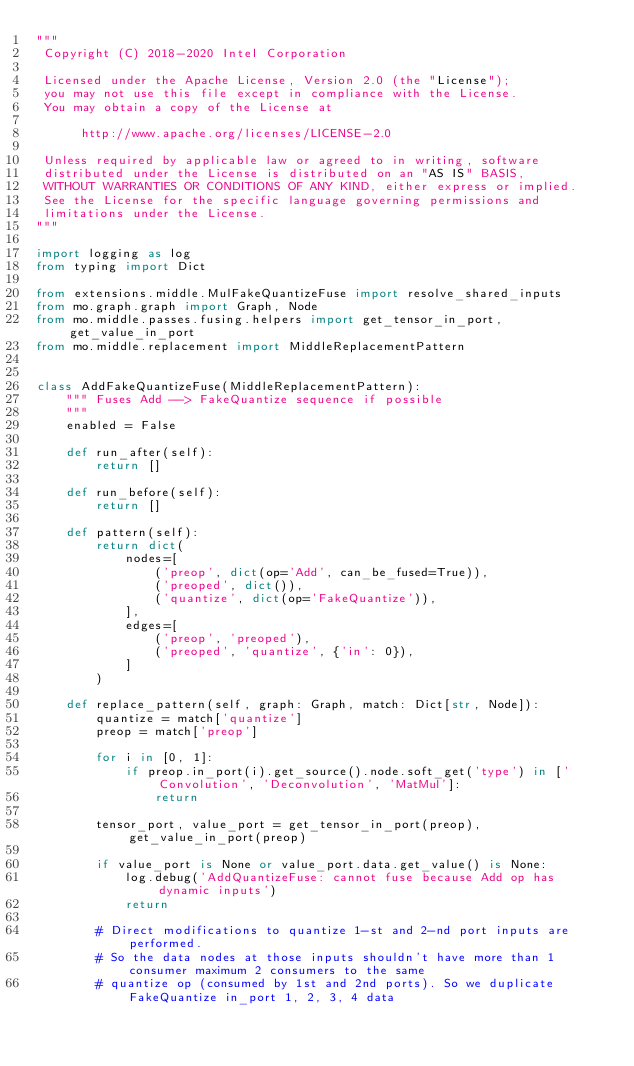<code> <loc_0><loc_0><loc_500><loc_500><_Python_>"""
 Copyright (C) 2018-2020 Intel Corporation

 Licensed under the Apache License, Version 2.0 (the "License");
 you may not use this file except in compliance with the License.
 You may obtain a copy of the License at

      http://www.apache.org/licenses/LICENSE-2.0

 Unless required by applicable law or agreed to in writing, software
 distributed under the License is distributed on an "AS IS" BASIS,
 WITHOUT WARRANTIES OR CONDITIONS OF ANY KIND, either express or implied.
 See the License for the specific language governing permissions and
 limitations under the License.
"""

import logging as log
from typing import Dict

from extensions.middle.MulFakeQuantizeFuse import resolve_shared_inputs
from mo.graph.graph import Graph, Node
from mo.middle.passes.fusing.helpers import get_tensor_in_port, get_value_in_port
from mo.middle.replacement import MiddleReplacementPattern


class AddFakeQuantizeFuse(MiddleReplacementPattern):
    """ Fuses Add --> FakeQuantize sequence if possible
    """
    enabled = False

    def run_after(self):
        return []

    def run_before(self):
        return []

    def pattern(self):
        return dict(
            nodes=[
                ('preop', dict(op='Add', can_be_fused=True)),
                ('preoped', dict()),
                ('quantize', dict(op='FakeQuantize')),
            ],
            edges=[
                ('preop', 'preoped'),
                ('preoped', 'quantize', {'in': 0}),
            ]
        )

    def replace_pattern(self, graph: Graph, match: Dict[str, Node]):
        quantize = match['quantize']
        preop = match['preop']

        for i in [0, 1]:
            if preop.in_port(i).get_source().node.soft_get('type') in ['Convolution', 'Deconvolution', 'MatMul']:
                return

        tensor_port, value_port = get_tensor_in_port(preop), get_value_in_port(preop)

        if value_port is None or value_port.data.get_value() is None:
            log.debug('AddQuantizeFuse: cannot fuse because Add op has dynamic inputs')
            return

        # Direct modifications to quantize 1-st and 2-nd port inputs are performed.
        # So the data nodes at those inputs shouldn't have more than 1 consumer maximum 2 consumers to the same
        # quantize op (consumed by 1st and 2nd ports). So we duplicate FakeQuantize in_port 1, 2, 3, 4 data</code> 